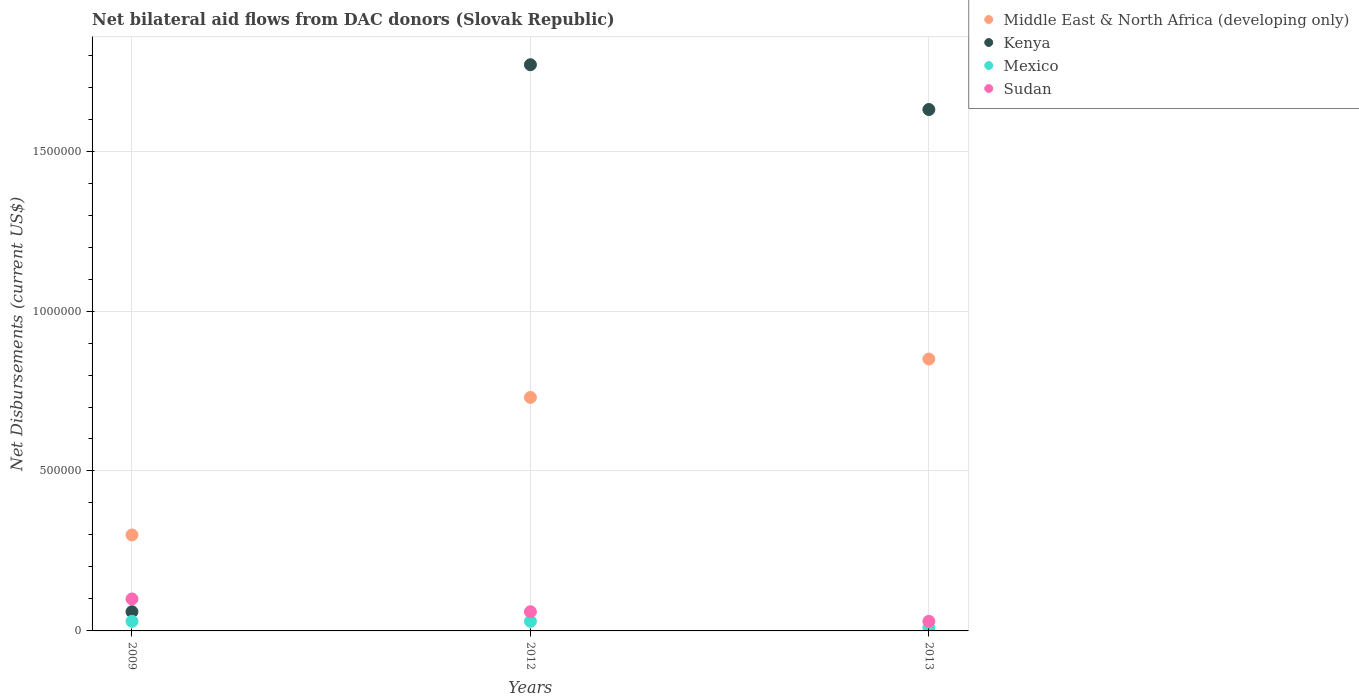How many different coloured dotlines are there?
Provide a short and direct response. 4. Is the number of dotlines equal to the number of legend labels?
Give a very brief answer. Yes. What is the net bilateral aid flows in Kenya in 2012?
Provide a succinct answer. 1.77e+06. Across all years, what is the maximum net bilateral aid flows in Kenya?
Your response must be concise. 1.77e+06. Across all years, what is the minimum net bilateral aid flows in Kenya?
Provide a short and direct response. 6.00e+04. What is the total net bilateral aid flows in Middle East & North Africa (developing only) in the graph?
Keep it short and to the point. 1.88e+06. What is the difference between the net bilateral aid flows in Sudan in 2009 and that in 2013?
Provide a succinct answer. 7.00e+04. What is the difference between the net bilateral aid flows in Sudan in 2013 and the net bilateral aid flows in Mexico in 2009?
Your response must be concise. 0. What is the average net bilateral aid flows in Kenya per year?
Keep it short and to the point. 1.15e+06. In the year 2013, what is the difference between the net bilateral aid flows in Middle East & North Africa (developing only) and net bilateral aid flows in Kenya?
Provide a succinct answer. -7.80e+05. What is the ratio of the net bilateral aid flows in Sudan in 2012 to that in 2013?
Provide a short and direct response. 2. Is the net bilateral aid flows in Mexico in 2012 less than that in 2013?
Offer a terse response. No. What is the difference between the highest and the lowest net bilateral aid flows in Kenya?
Offer a terse response. 1.71e+06. Is it the case that in every year, the sum of the net bilateral aid flows in Kenya and net bilateral aid flows in Mexico  is greater than the net bilateral aid flows in Middle East & North Africa (developing only)?
Keep it short and to the point. No. Is the net bilateral aid flows in Mexico strictly greater than the net bilateral aid flows in Middle East & North Africa (developing only) over the years?
Keep it short and to the point. No. How many dotlines are there?
Your answer should be very brief. 4. Are the values on the major ticks of Y-axis written in scientific E-notation?
Provide a short and direct response. No. Does the graph contain any zero values?
Offer a very short reply. No. Where does the legend appear in the graph?
Offer a terse response. Top right. How are the legend labels stacked?
Make the answer very short. Vertical. What is the title of the graph?
Ensure brevity in your answer.  Net bilateral aid flows from DAC donors (Slovak Republic). What is the label or title of the X-axis?
Offer a terse response. Years. What is the label or title of the Y-axis?
Give a very brief answer. Net Disbursements (current US$). What is the Net Disbursements (current US$) in Middle East & North Africa (developing only) in 2009?
Ensure brevity in your answer.  3.00e+05. What is the Net Disbursements (current US$) in Sudan in 2009?
Your answer should be very brief. 1.00e+05. What is the Net Disbursements (current US$) of Middle East & North Africa (developing only) in 2012?
Make the answer very short. 7.30e+05. What is the Net Disbursements (current US$) of Kenya in 2012?
Your response must be concise. 1.77e+06. What is the Net Disbursements (current US$) in Mexico in 2012?
Your response must be concise. 3.00e+04. What is the Net Disbursements (current US$) of Middle East & North Africa (developing only) in 2013?
Offer a terse response. 8.50e+05. What is the Net Disbursements (current US$) in Kenya in 2013?
Provide a short and direct response. 1.63e+06. What is the Net Disbursements (current US$) in Mexico in 2013?
Give a very brief answer. 10000. What is the Net Disbursements (current US$) in Sudan in 2013?
Give a very brief answer. 3.00e+04. Across all years, what is the maximum Net Disbursements (current US$) in Middle East & North Africa (developing only)?
Ensure brevity in your answer.  8.50e+05. Across all years, what is the maximum Net Disbursements (current US$) in Kenya?
Provide a short and direct response. 1.77e+06. Across all years, what is the maximum Net Disbursements (current US$) in Sudan?
Offer a very short reply. 1.00e+05. Across all years, what is the minimum Net Disbursements (current US$) in Mexico?
Keep it short and to the point. 10000. Across all years, what is the minimum Net Disbursements (current US$) of Sudan?
Give a very brief answer. 3.00e+04. What is the total Net Disbursements (current US$) in Middle East & North Africa (developing only) in the graph?
Keep it short and to the point. 1.88e+06. What is the total Net Disbursements (current US$) in Kenya in the graph?
Your answer should be very brief. 3.46e+06. What is the total Net Disbursements (current US$) in Sudan in the graph?
Offer a very short reply. 1.90e+05. What is the difference between the Net Disbursements (current US$) in Middle East & North Africa (developing only) in 2009 and that in 2012?
Your response must be concise. -4.30e+05. What is the difference between the Net Disbursements (current US$) of Kenya in 2009 and that in 2012?
Provide a short and direct response. -1.71e+06. What is the difference between the Net Disbursements (current US$) in Mexico in 2009 and that in 2012?
Your response must be concise. 0. What is the difference between the Net Disbursements (current US$) in Sudan in 2009 and that in 2012?
Make the answer very short. 4.00e+04. What is the difference between the Net Disbursements (current US$) of Middle East & North Africa (developing only) in 2009 and that in 2013?
Your response must be concise. -5.50e+05. What is the difference between the Net Disbursements (current US$) in Kenya in 2009 and that in 2013?
Provide a short and direct response. -1.57e+06. What is the difference between the Net Disbursements (current US$) in Mexico in 2009 and that in 2013?
Provide a succinct answer. 2.00e+04. What is the difference between the Net Disbursements (current US$) in Sudan in 2009 and that in 2013?
Provide a succinct answer. 7.00e+04. What is the difference between the Net Disbursements (current US$) in Middle East & North Africa (developing only) in 2012 and that in 2013?
Provide a succinct answer. -1.20e+05. What is the difference between the Net Disbursements (current US$) of Kenya in 2012 and that in 2013?
Make the answer very short. 1.40e+05. What is the difference between the Net Disbursements (current US$) of Mexico in 2012 and that in 2013?
Provide a succinct answer. 2.00e+04. What is the difference between the Net Disbursements (current US$) in Middle East & North Africa (developing only) in 2009 and the Net Disbursements (current US$) in Kenya in 2012?
Offer a terse response. -1.47e+06. What is the difference between the Net Disbursements (current US$) of Kenya in 2009 and the Net Disbursements (current US$) of Mexico in 2012?
Make the answer very short. 3.00e+04. What is the difference between the Net Disbursements (current US$) in Kenya in 2009 and the Net Disbursements (current US$) in Sudan in 2012?
Offer a very short reply. 0. What is the difference between the Net Disbursements (current US$) in Mexico in 2009 and the Net Disbursements (current US$) in Sudan in 2012?
Give a very brief answer. -3.00e+04. What is the difference between the Net Disbursements (current US$) in Middle East & North Africa (developing only) in 2009 and the Net Disbursements (current US$) in Kenya in 2013?
Ensure brevity in your answer.  -1.33e+06. What is the difference between the Net Disbursements (current US$) in Middle East & North Africa (developing only) in 2012 and the Net Disbursements (current US$) in Kenya in 2013?
Your response must be concise. -9.00e+05. What is the difference between the Net Disbursements (current US$) in Middle East & North Africa (developing only) in 2012 and the Net Disbursements (current US$) in Mexico in 2013?
Provide a short and direct response. 7.20e+05. What is the difference between the Net Disbursements (current US$) in Kenya in 2012 and the Net Disbursements (current US$) in Mexico in 2013?
Your response must be concise. 1.76e+06. What is the difference between the Net Disbursements (current US$) of Kenya in 2012 and the Net Disbursements (current US$) of Sudan in 2013?
Offer a very short reply. 1.74e+06. What is the difference between the Net Disbursements (current US$) in Mexico in 2012 and the Net Disbursements (current US$) in Sudan in 2013?
Ensure brevity in your answer.  0. What is the average Net Disbursements (current US$) of Middle East & North Africa (developing only) per year?
Give a very brief answer. 6.27e+05. What is the average Net Disbursements (current US$) of Kenya per year?
Your answer should be very brief. 1.15e+06. What is the average Net Disbursements (current US$) of Mexico per year?
Ensure brevity in your answer.  2.33e+04. What is the average Net Disbursements (current US$) of Sudan per year?
Your answer should be compact. 6.33e+04. In the year 2009, what is the difference between the Net Disbursements (current US$) of Middle East & North Africa (developing only) and Net Disbursements (current US$) of Kenya?
Your answer should be compact. 2.40e+05. In the year 2009, what is the difference between the Net Disbursements (current US$) of Kenya and Net Disbursements (current US$) of Mexico?
Offer a very short reply. 3.00e+04. In the year 2009, what is the difference between the Net Disbursements (current US$) of Mexico and Net Disbursements (current US$) of Sudan?
Ensure brevity in your answer.  -7.00e+04. In the year 2012, what is the difference between the Net Disbursements (current US$) of Middle East & North Africa (developing only) and Net Disbursements (current US$) of Kenya?
Make the answer very short. -1.04e+06. In the year 2012, what is the difference between the Net Disbursements (current US$) in Middle East & North Africa (developing only) and Net Disbursements (current US$) in Mexico?
Offer a very short reply. 7.00e+05. In the year 2012, what is the difference between the Net Disbursements (current US$) in Middle East & North Africa (developing only) and Net Disbursements (current US$) in Sudan?
Make the answer very short. 6.70e+05. In the year 2012, what is the difference between the Net Disbursements (current US$) in Kenya and Net Disbursements (current US$) in Mexico?
Make the answer very short. 1.74e+06. In the year 2012, what is the difference between the Net Disbursements (current US$) of Kenya and Net Disbursements (current US$) of Sudan?
Offer a very short reply. 1.71e+06. In the year 2012, what is the difference between the Net Disbursements (current US$) of Mexico and Net Disbursements (current US$) of Sudan?
Your answer should be very brief. -3.00e+04. In the year 2013, what is the difference between the Net Disbursements (current US$) in Middle East & North Africa (developing only) and Net Disbursements (current US$) in Kenya?
Make the answer very short. -7.80e+05. In the year 2013, what is the difference between the Net Disbursements (current US$) of Middle East & North Africa (developing only) and Net Disbursements (current US$) of Mexico?
Provide a succinct answer. 8.40e+05. In the year 2013, what is the difference between the Net Disbursements (current US$) in Middle East & North Africa (developing only) and Net Disbursements (current US$) in Sudan?
Provide a succinct answer. 8.20e+05. In the year 2013, what is the difference between the Net Disbursements (current US$) of Kenya and Net Disbursements (current US$) of Mexico?
Your answer should be very brief. 1.62e+06. In the year 2013, what is the difference between the Net Disbursements (current US$) in Kenya and Net Disbursements (current US$) in Sudan?
Provide a succinct answer. 1.60e+06. In the year 2013, what is the difference between the Net Disbursements (current US$) in Mexico and Net Disbursements (current US$) in Sudan?
Keep it short and to the point. -2.00e+04. What is the ratio of the Net Disbursements (current US$) in Middle East & North Africa (developing only) in 2009 to that in 2012?
Make the answer very short. 0.41. What is the ratio of the Net Disbursements (current US$) in Kenya in 2009 to that in 2012?
Ensure brevity in your answer.  0.03. What is the ratio of the Net Disbursements (current US$) in Sudan in 2009 to that in 2012?
Your answer should be very brief. 1.67. What is the ratio of the Net Disbursements (current US$) in Middle East & North Africa (developing only) in 2009 to that in 2013?
Provide a succinct answer. 0.35. What is the ratio of the Net Disbursements (current US$) of Kenya in 2009 to that in 2013?
Make the answer very short. 0.04. What is the ratio of the Net Disbursements (current US$) of Middle East & North Africa (developing only) in 2012 to that in 2013?
Offer a terse response. 0.86. What is the ratio of the Net Disbursements (current US$) in Kenya in 2012 to that in 2013?
Provide a short and direct response. 1.09. What is the difference between the highest and the lowest Net Disbursements (current US$) of Middle East & North Africa (developing only)?
Provide a succinct answer. 5.50e+05. What is the difference between the highest and the lowest Net Disbursements (current US$) in Kenya?
Make the answer very short. 1.71e+06. What is the difference between the highest and the lowest Net Disbursements (current US$) of Mexico?
Offer a terse response. 2.00e+04. What is the difference between the highest and the lowest Net Disbursements (current US$) in Sudan?
Keep it short and to the point. 7.00e+04. 